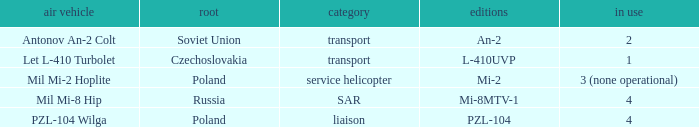Tell me the origin for mi-2 Poland. 